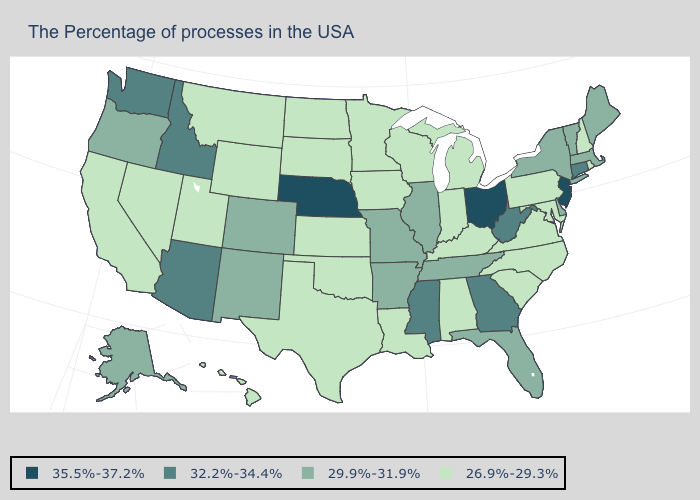What is the value of Pennsylvania?
Answer briefly. 26.9%-29.3%. What is the value of California?
Concise answer only. 26.9%-29.3%. Is the legend a continuous bar?
Keep it brief. No. Among the states that border Nevada , which have the lowest value?
Be succinct. Utah, California. Does the first symbol in the legend represent the smallest category?
Keep it brief. No. Does Oklahoma have the same value as Georgia?
Concise answer only. No. What is the highest value in states that border Wisconsin?
Concise answer only. 29.9%-31.9%. Does Washington have the same value as North Carolina?
Give a very brief answer. No. Does Idaho have the highest value in the West?
Answer briefly. Yes. Which states have the lowest value in the MidWest?
Give a very brief answer. Michigan, Indiana, Wisconsin, Minnesota, Iowa, Kansas, South Dakota, North Dakota. What is the value of Wyoming?
Answer briefly. 26.9%-29.3%. What is the value of Rhode Island?
Write a very short answer. 26.9%-29.3%. What is the lowest value in the West?
Quick response, please. 26.9%-29.3%. Does the first symbol in the legend represent the smallest category?
Write a very short answer. No. What is the value of Mississippi?
Concise answer only. 32.2%-34.4%. 